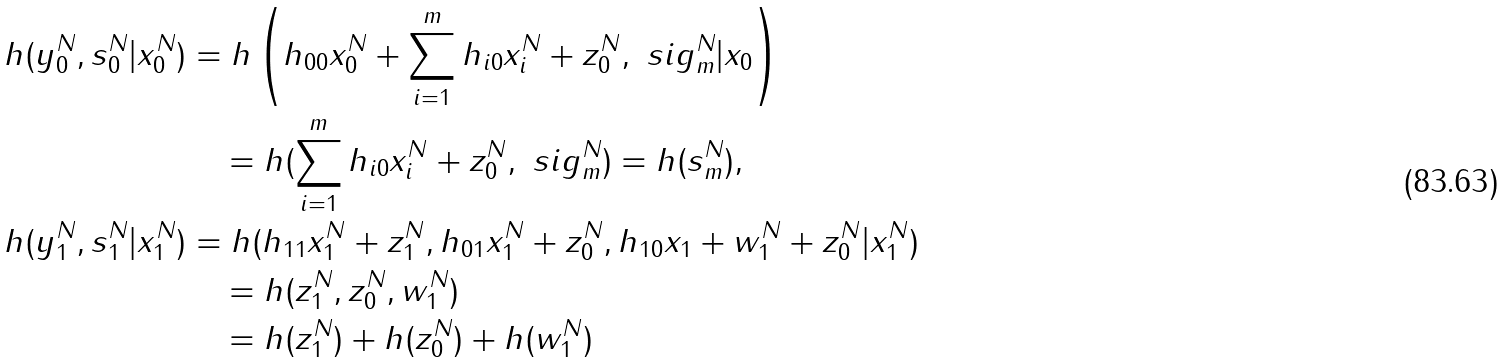Convert formula to latex. <formula><loc_0><loc_0><loc_500><loc_500>h ( y _ { 0 } ^ { N } , s _ { 0 } ^ { N } | x _ { 0 } ^ { N } ) & = h \left ( h _ { 0 0 } x _ { 0 } ^ { N } + \sum _ { i = 1 } ^ { m } h _ { i 0 } x _ { i } ^ { N } + z _ { 0 } ^ { N } , \ s i g _ { m } ^ { N } | x _ { 0 } \right ) \\ & \quad = h ( \sum _ { i = 1 } ^ { m } h _ { i 0 } x _ { i } ^ { N } + z _ { 0 } ^ { N } , \ s i g _ { m } ^ { N } ) = h ( s _ { m } ^ { N } ) , \\ h ( y _ { 1 } ^ { N } , s _ { 1 } ^ { N } | x _ { 1 } ^ { N } ) & = h ( h _ { 1 1 } x _ { 1 } ^ { N } + z _ { 1 } ^ { N } , h _ { 0 1 } x _ { 1 } ^ { N } + z _ { 0 } ^ { N } , h _ { 1 0 } x _ { 1 } + w _ { 1 } ^ { N } + z _ { 0 } ^ { N } | x _ { 1 } ^ { N } ) \\ & \quad = h ( z _ { 1 } ^ { N } , z _ { 0 } ^ { N } , w _ { 1 } ^ { N } ) \\ & \quad = h ( z _ { 1 } ^ { N } ) + h ( z _ { 0 } ^ { N } ) + h ( w _ { 1 } ^ { N } )</formula> 